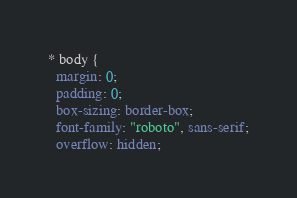<code> <loc_0><loc_0><loc_500><loc_500><_CSS_>* body {
  margin: 0;
  padding: 0;
  box-sizing: border-box;
  font-family: "roboto", sans-serif;
  overflow: hidden;</code> 